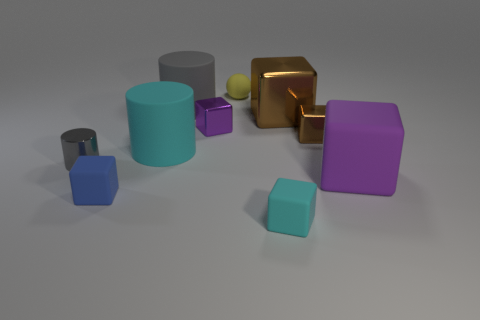Subtract all blue rubber cubes. How many cubes are left? 5 Subtract all cyan cubes. How many cubes are left? 5 Subtract all red blocks. Subtract all yellow balls. How many blocks are left? 6 Subtract all cylinders. How many objects are left? 7 Subtract 0 blue balls. How many objects are left? 10 Subtract all gray matte things. Subtract all large cyan objects. How many objects are left? 8 Add 4 large purple blocks. How many large purple blocks are left? 5 Add 3 gray cylinders. How many gray cylinders exist? 5 